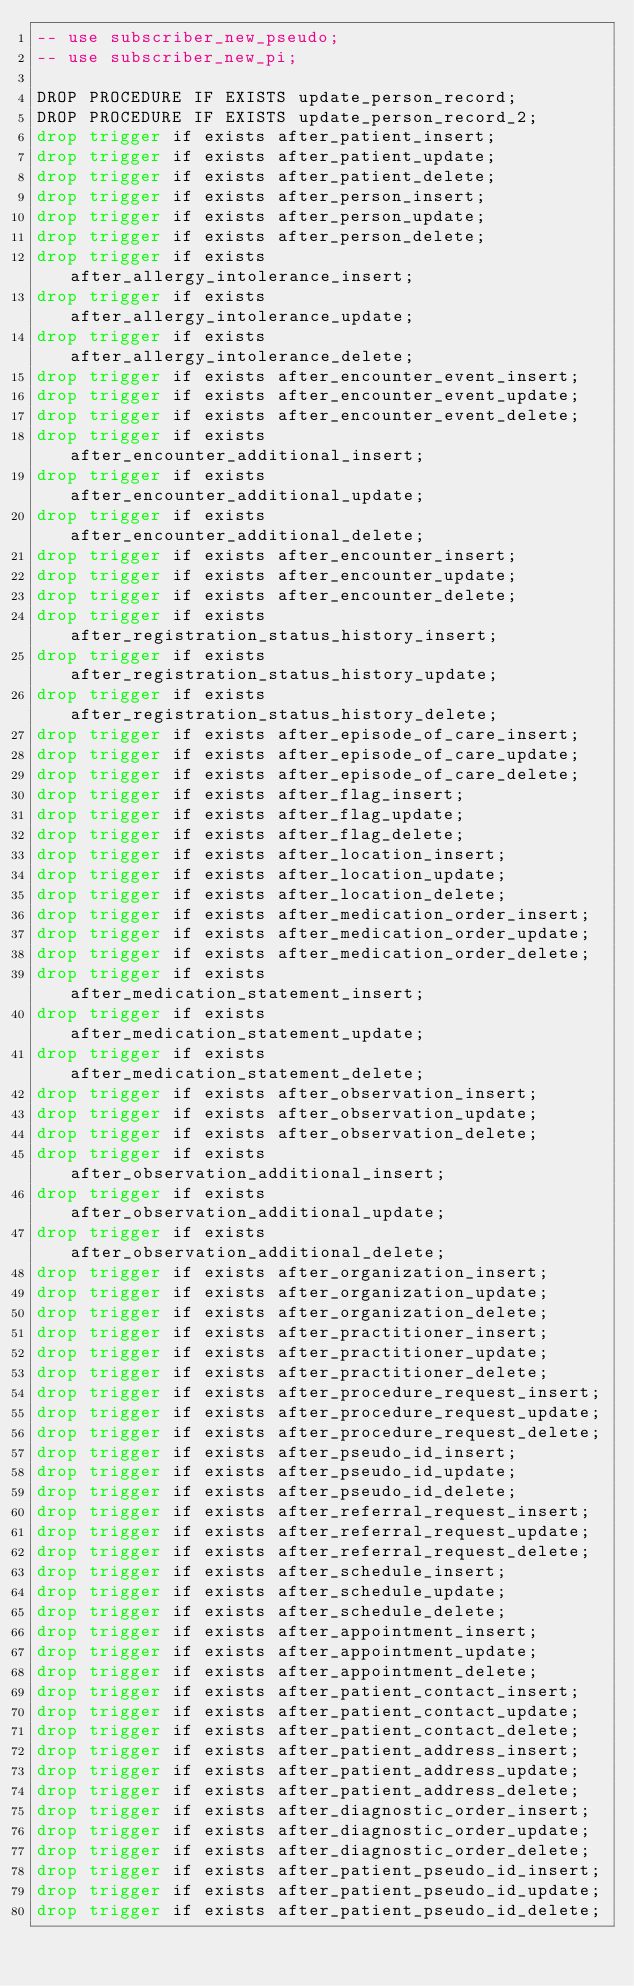<code> <loc_0><loc_0><loc_500><loc_500><_SQL_>-- use subscriber_new_pseudo;
-- use subscriber_new_pi;

DROP PROCEDURE IF EXISTS update_person_record;
DROP PROCEDURE IF EXISTS update_person_record_2;
drop trigger if exists after_patient_insert;
drop trigger if exists after_patient_update;
drop trigger if exists after_patient_delete;
drop trigger if exists after_person_insert;
drop trigger if exists after_person_update;
drop trigger if exists after_person_delete;
drop trigger if exists after_allergy_intolerance_insert;
drop trigger if exists after_allergy_intolerance_update;
drop trigger if exists after_allergy_intolerance_delete;
drop trigger if exists after_encounter_event_insert;
drop trigger if exists after_encounter_event_update;
drop trigger if exists after_encounter_event_delete;
drop trigger if exists after_encounter_additional_insert;
drop trigger if exists after_encounter_additional_update;
drop trigger if exists after_encounter_additional_delete;
drop trigger if exists after_encounter_insert;
drop trigger if exists after_encounter_update;
drop trigger if exists after_encounter_delete;
drop trigger if exists after_registration_status_history_insert;
drop trigger if exists after_registration_status_history_update;
drop trigger if exists after_registration_status_history_delete;
drop trigger if exists after_episode_of_care_insert;
drop trigger if exists after_episode_of_care_update;
drop trigger if exists after_episode_of_care_delete;
drop trigger if exists after_flag_insert;
drop trigger if exists after_flag_update;
drop trigger if exists after_flag_delete;
drop trigger if exists after_location_insert;
drop trigger if exists after_location_update;
drop trigger if exists after_location_delete;
drop trigger if exists after_medication_order_insert;
drop trigger if exists after_medication_order_update;
drop trigger if exists after_medication_order_delete;
drop trigger if exists after_medication_statement_insert;
drop trigger if exists after_medication_statement_update;
drop trigger if exists after_medication_statement_delete;
drop trigger if exists after_observation_insert;
drop trigger if exists after_observation_update;
drop trigger if exists after_observation_delete;
drop trigger if exists after_observation_additional_insert;
drop trigger if exists after_observation_additional_update;
drop trigger if exists after_observation_additional_delete;
drop trigger if exists after_organization_insert;
drop trigger if exists after_organization_update;
drop trigger if exists after_organization_delete;
drop trigger if exists after_practitioner_insert;
drop trigger if exists after_practitioner_update;
drop trigger if exists after_practitioner_delete;
drop trigger if exists after_procedure_request_insert;
drop trigger if exists after_procedure_request_update;
drop trigger if exists after_procedure_request_delete;
drop trigger if exists after_pseudo_id_insert;
drop trigger if exists after_pseudo_id_update;
drop trigger if exists after_pseudo_id_delete;
drop trigger if exists after_referral_request_insert;
drop trigger if exists after_referral_request_update;
drop trigger if exists after_referral_request_delete;
drop trigger if exists after_schedule_insert;
drop trigger if exists after_schedule_update;
drop trigger if exists after_schedule_delete;
drop trigger if exists after_appointment_insert;
drop trigger if exists after_appointment_update;
drop trigger if exists after_appointment_delete;
drop trigger if exists after_patient_contact_insert;
drop trigger if exists after_patient_contact_update;
drop trigger if exists after_patient_contact_delete;
drop trigger if exists after_patient_address_insert;
drop trigger if exists after_patient_address_update;
drop trigger if exists after_patient_address_delete;
drop trigger if exists after_diagnostic_order_insert;
drop trigger if exists after_diagnostic_order_update;
drop trigger if exists after_diagnostic_order_delete;
drop trigger if exists after_patient_pseudo_id_insert;
drop trigger if exists after_patient_pseudo_id_update;
drop trigger if exists after_patient_pseudo_id_delete;</code> 